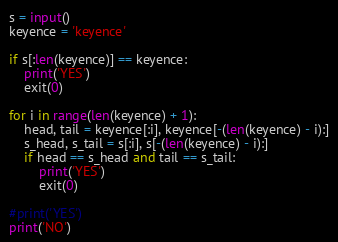Convert code to text. <code><loc_0><loc_0><loc_500><loc_500><_Python_>s = input()
keyence = 'keyence'

if s[:len(keyence)] == keyence:
    print('YES')
    exit(0)

for i in range(len(keyence) + 1):
    head, tail = keyence[:i], keyence[-(len(keyence) - i):]
    s_head, s_tail = s[:i], s[-(len(keyence) - i):]
    if head == s_head and tail == s_tail:
        print('YES')
        exit(0)

#print('YES')
print('NO')
</code> 